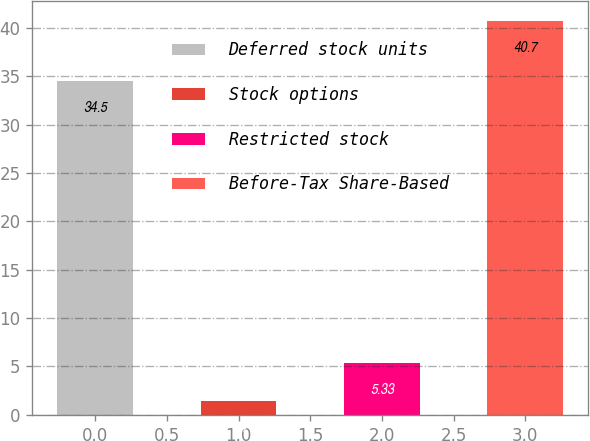<chart> <loc_0><loc_0><loc_500><loc_500><bar_chart><fcel>Deferred stock units<fcel>Stock options<fcel>Restricted stock<fcel>Before-Tax Share-Based<nl><fcel>34.5<fcel>1.4<fcel>5.33<fcel>40.7<nl></chart> 